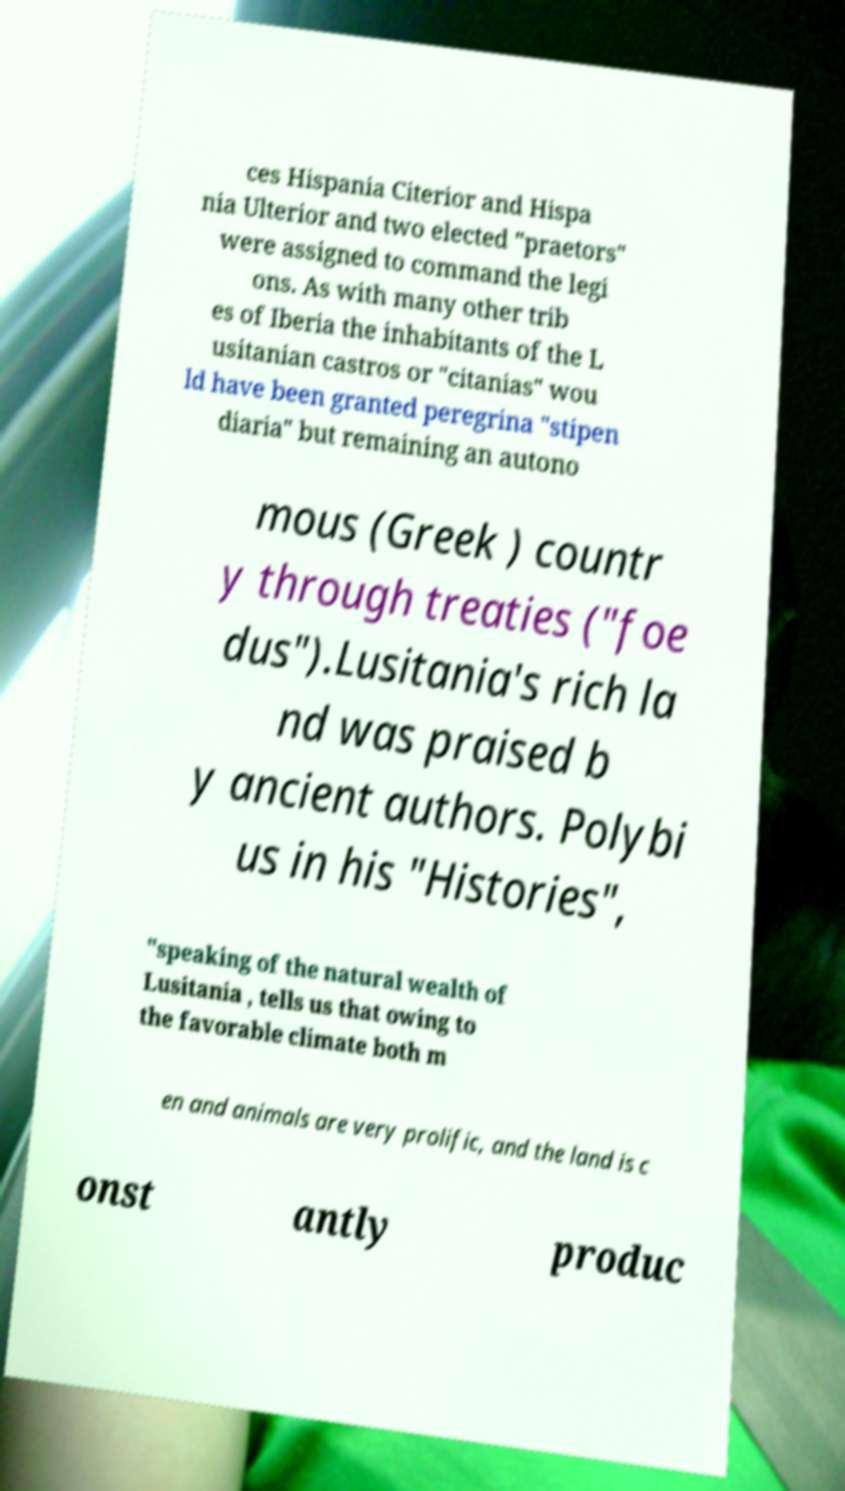Could you extract and type out the text from this image? ces Hispania Citerior and Hispa nia Ulterior and two elected "praetors" were assigned to command the legi ons. As with many other trib es of Iberia the inhabitants of the L usitanian castros or "citanias" wou ld have been granted peregrina "stipen diaria" but remaining an autono mous (Greek ) countr y through treaties ("foe dus").Lusitania's rich la nd was praised b y ancient authors. Polybi us in his "Histories", "speaking of the natural wealth of Lusitania , tells us that owing to the favorable climate both m en and animals are very prolific, and the land is c onst antly produc 